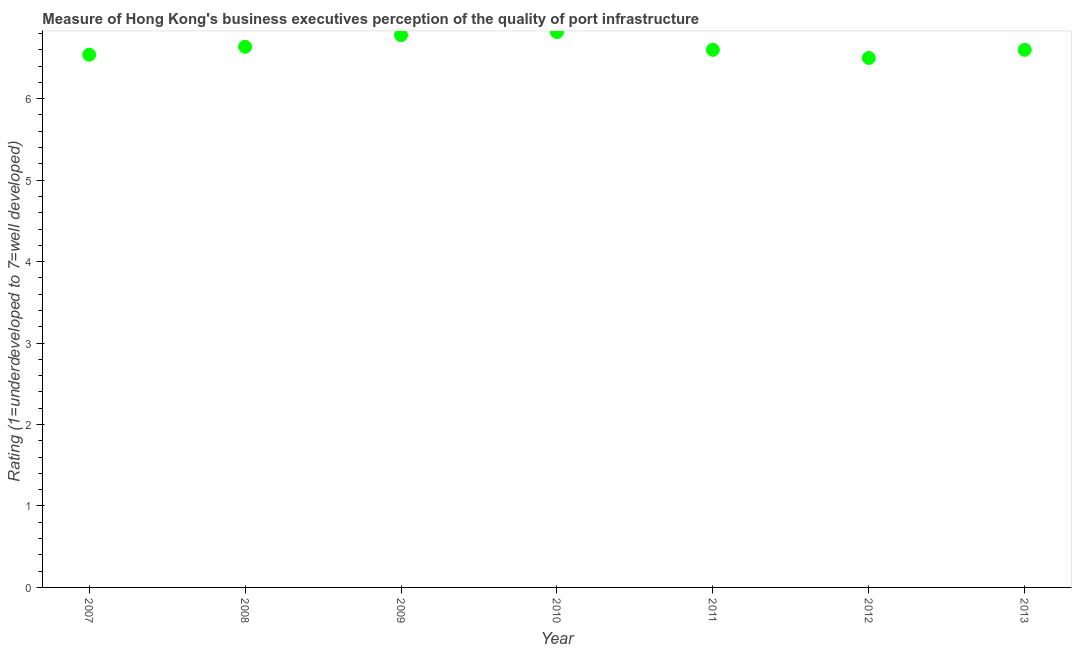What is the rating measuring quality of port infrastructure in 2008?
Your answer should be compact. 6.64. Across all years, what is the maximum rating measuring quality of port infrastructure?
Make the answer very short. 6.82. Across all years, what is the minimum rating measuring quality of port infrastructure?
Your response must be concise. 6.5. In which year was the rating measuring quality of port infrastructure maximum?
Your answer should be very brief. 2010. In which year was the rating measuring quality of port infrastructure minimum?
Give a very brief answer. 2012. What is the sum of the rating measuring quality of port infrastructure?
Provide a succinct answer. 46.47. What is the difference between the rating measuring quality of port infrastructure in 2009 and 2012?
Ensure brevity in your answer.  0.28. What is the average rating measuring quality of port infrastructure per year?
Offer a very short reply. 6.64. What is the ratio of the rating measuring quality of port infrastructure in 2008 to that in 2010?
Offer a very short reply. 0.97. Is the rating measuring quality of port infrastructure in 2010 less than that in 2013?
Your response must be concise. No. What is the difference between the highest and the second highest rating measuring quality of port infrastructure?
Give a very brief answer. 0.04. Is the sum of the rating measuring quality of port infrastructure in 2009 and 2012 greater than the maximum rating measuring quality of port infrastructure across all years?
Your answer should be very brief. Yes. What is the difference between the highest and the lowest rating measuring quality of port infrastructure?
Provide a succinct answer. 0.32. How many dotlines are there?
Provide a succinct answer. 1. What is the difference between two consecutive major ticks on the Y-axis?
Provide a succinct answer. 1. Are the values on the major ticks of Y-axis written in scientific E-notation?
Ensure brevity in your answer.  No. Does the graph contain any zero values?
Your response must be concise. No. Does the graph contain grids?
Ensure brevity in your answer.  No. What is the title of the graph?
Provide a succinct answer. Measure of Hong Kong's business executives perception of the quality of port infrastructure. What is the label or title of the Y-axis?
Offer a terse response. Rating (1=underdeveloped to 7=well developed) . What is the Rating (1=underdeveloped to 7=well developed)  in 2007?
Offer a very short reply. 6.54. What is the Rating (1=underdeveloped to 7=well developed)  in 2008?
Keep it short and to the point. 6.64. What is the Rating (1=underdeveloped to 7=well developed)  in 2009?
Your answer should be compact. 6.78. What is the Rating (1=underdeveloped to 7=well developed)  in 2010?
Provide a succinct answer. 6.82. What is the Rating (1=underdeveloped to 7=well developed)  in 2012?
Provide a short and direct response. 6.5. What is the Rating (1=underdeveloped to 7=well developed)  in 2013?
Ensure brevity in your answer.  6.6. What is the difference between the Rating (1=underdeveloped to 7=well developed)  in 2007 and 2008?
Give a very brief answer. -0.1. What is the difference between the Rating (1=underdeveloped to 7=well developed)  in 2007 and 2009?
Provide a short and direct response. -0.24. What is the difference between the Rating (1=underdeveloped to 7=well developed)  in 2007 and 2010?
Keep it short and to the point. -0.28. What is the difference between the Rating (1=underdeveloped to 7=well developed)  in 2007 and 2011?
Keep it short and to the point. -0.06. What is the difference between the Rating (1=underdeveloped to 7=well developed)  in 2007 and 2012?
Make the answer very short. 0.04. What is the difference between the Rating (1=underdeveloped to 7=well developed)  in 2007 and 2013?
Your response must be concise. -0.06. What is the difference between the Rating (1=underdeveloped to 7=well developed)  in 2008 and 2009?
Ensure brevity in your answer.  -0.14. What is the difference between the Rating (1=underdeveloped to 7=well developed)  in 2008 and 2010?
Ensure brevity in your answer.  -0.18. What is the difference between the Rating (1=underdeveloped to 7=well developed)  in 2008 and 2011?
Make the answer very short. 0.04. What is the difference between the Rating (1=underdeveloped to 7=well developed)  in 2008 and 2012?
Your answer should be very brief. 0.14. What is the difference between the Rating (1=underdeveloped to 7=well developed)  in 2008 and 2013?
Provide a succinct answer. 0.04. What is the difference between the Rating (1=underdeveloped to 7=well developed)  in 2009 and 2010?
Ensure brevity in your answer.  -0.04. What is the difference between the Rating (1=underdeveloped to 7=well developed)  in 2009 and 2011?
Make the answer very short. 0.18. What is the difference between the Rating (1=underdeveloped to 7=well developed)  in 2009 and 2012?
Ensure brevity in your answer.  0.28. What is the difference between the Rating (1=underdeveloped to 7=well developed)  in 2009 and 2013?
Offer a very short reply. 0.18. What is the difference between the Rating (1=underdeveloped to 7=well developed)  in 2010 and 2011?
Provide a succinct answer. 0.22. What is the difference between the Rating (1=underdeveloped to 7=well developed)  in 2010 and 2012?
Keep it short and to the point. 0.32. What is the difference between the Rating (1=underdeveloped to 7=well developed)  in 2010 and 2013?
Make the answer very short. 0.22. What is the difference between the Rating (1=underdeveloped to 7=well developed)  in 2011 and 2012?
Offer a terse response. 0.1. What is the ratio of the Rating (1=underdeveloped to 7=well developed)  in 2007 to that in 2011?
Your answer should be very brief. 0.99. What is the ratio of the Rating (1=underdeveloped to 7=well developed)  in 2007 to that in 2013?
Make the answer very short. 0.99. What is the ratio of the Rating (1=underdeveloped to 7=well developed)  in 2008 to that in 2010?
Your answer should be very brief. 0.97. What is the ratio of the Rating (1=underdeveloped to 7=well developed)  in 2008 to that in 2012?
Make the answer very short. 1.02. What is the ratio of the Rating (1=underdeveloped to 7=well developed)  in 2008 to that in 2013?
Your response must be concise. 1.01. What is the ratio of the Rating (1=underdeveloped to 7=well developed)  in 2009 to that in 2012?
Make the answer very short. 1.04. What is the ratio of the Rating (1=underdeveloped to 7=well developed)  in 2010 to that in 2011?
Your answer should be compact. 1.03. What is the ratio of the Rating (1=underdeveloped to 7=well developed)  in 2010 to that in 2012?
Provide a short and direct response. 1.05. What is the ratio of the Rating (1=underdeveloped to 7=well developed)  in 2010 to that in 2013?
Give a very brief answer. 1.03. 